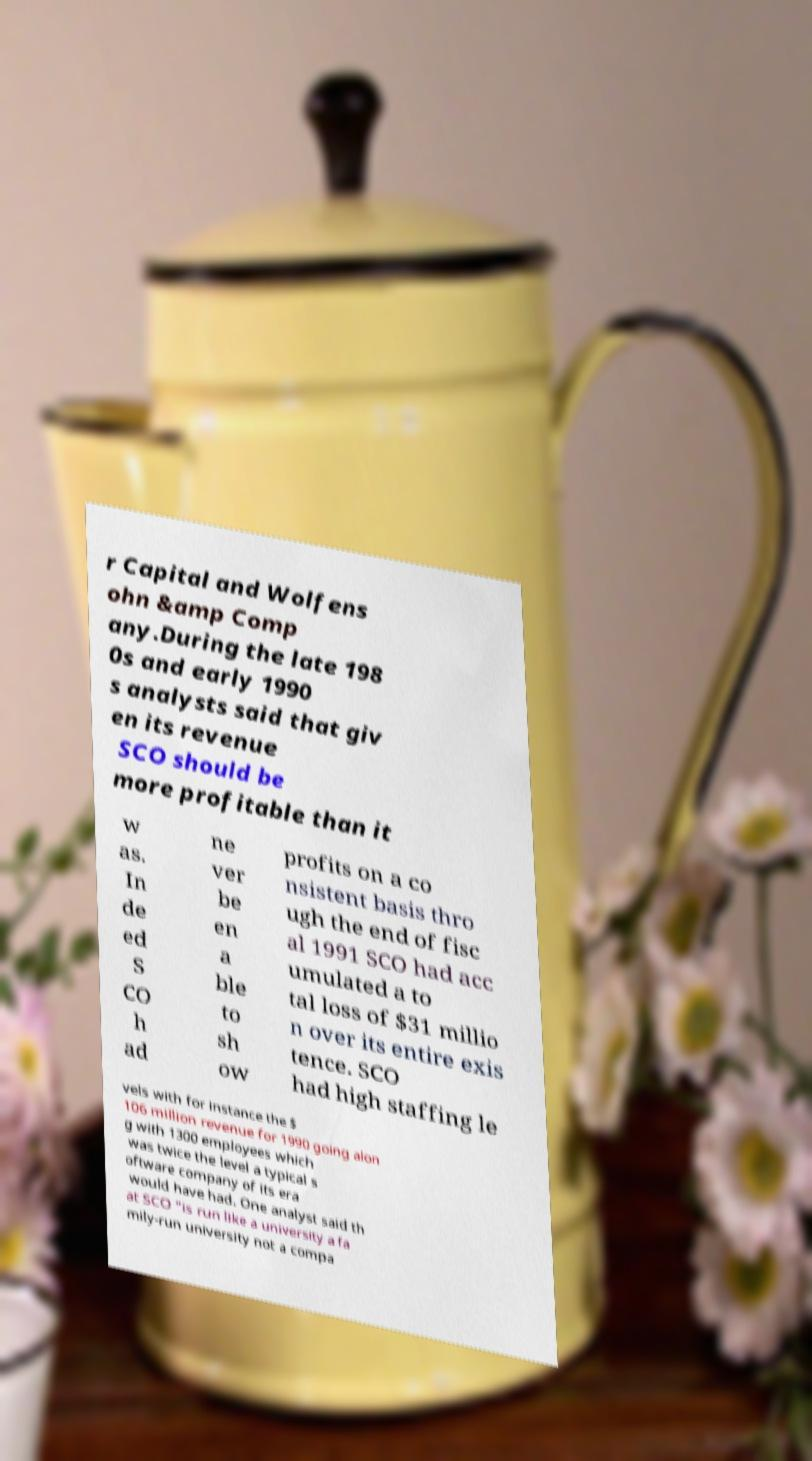Please identify and transcribe the text found in this image. r Capital and Wolfens ohn &amp Comp any.During the late 198 0s and early 1990 s analysts said that giv en its revenue SCO should be more profitable than it w as. In de ed S CO h ad ne ver be en a ble to sh ow profits on a co nsistent basis thro ugh the end of fisc al 1991 SCO had acc umulated a to tal loss of $31 millio n over its entire exis tence. SCO had high staffing le vels with for instance the $ 106 million revenue for 1990 going alon g with 1300 employees which was twice the level a typical s oftware company of its era would have had. One analyst said th at SCO "is run like a university a fa mily-run university not a compa 